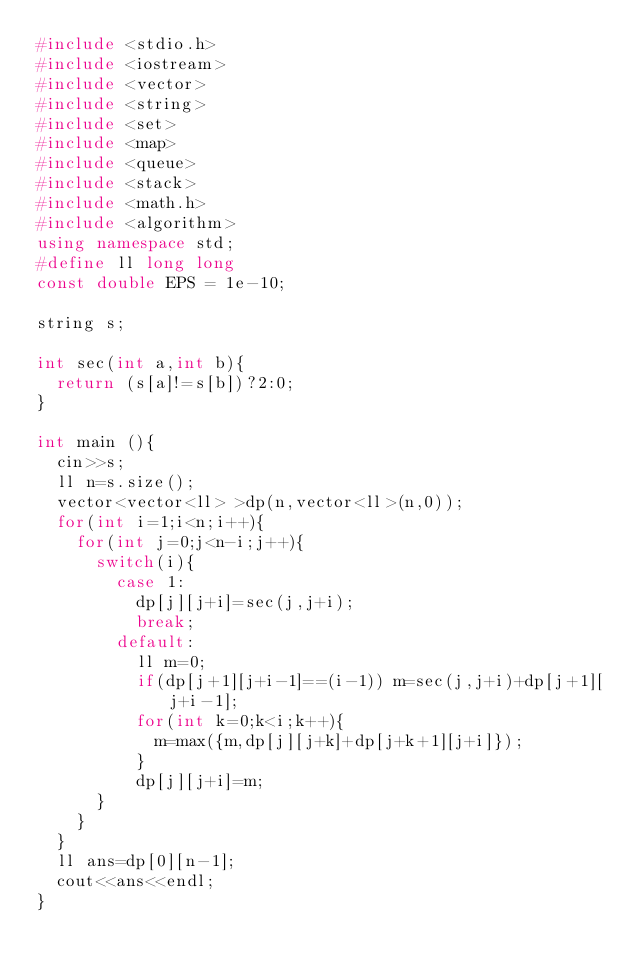<code> <loc_0><loc_0><loc_500><loc_500><_C++_>#include <stdio.h>
#include <iostream>
#include <vector>
#include <string>
#include <set>
#include <map>
#include <queue>
#include <stack>
#include <math.h>
#include <algorithm>
using namespace std;
#define ll long long
const double EPS = 1e-10;

string s;

int sec(int a,int b){
  return (s[a]!=s[b])?2:0;
}

int main (){
  cin>>s;
  ll n=s.size();
  vector<vector<ll> >dp(n,vector<ll>(n,0));
  for(int i=1;i<n;i++){
    for(int j=0;j<n-i;j++){
      switch(i){
        case 1:
          dp[j][j+i]=sec(j,j+i);
          break;
        default:
          ll m=0;
          if(dp[j+1][j+i-1]==(i-1)) m=sec(j,j+i)+dp[j+1][j+i-1];
          for(int k=0;k<i;k++){
            m=max({m,dp[j][j+k]+dp[j+k+1][j+i]});
          }
          dp[j][j+i]=m;
      }
    }
  }
  ll ans=dp[0][n-1];
  cout<<ans<<endl;
}
</code> 